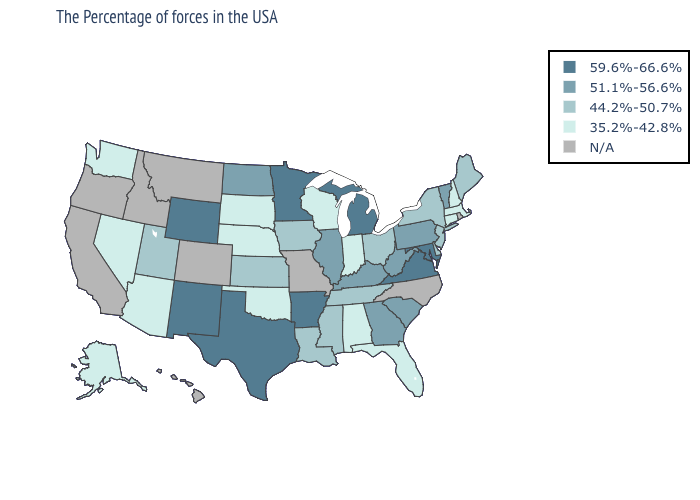Name the states that have a value in the range N/A?
Write a very short answer. Rhode Island, North Carolina, Missouri, Colorado, Montana, Idaho, California, Oregon, Hawaii. Name the states that have a value in the range 35.2%-42.8%?
Keep it brief. Massachusetts, New Hampshire, Connecticut, Florida, Indiana, Alabama, Wisconsin, Nebraska, Oklahoma, South Dakota, Arizona, Nevada, Washington, Alaska. Which states have the highest value in the USA?
Write a very short answer. Maryland, Virginia, Michigan, Arkansas, Minnesota, Texas, Wyoming, New Mexico. Among the states that border North Dakota , which have the highest value?
Short answer required. Minnesota. What is the value of Indiana?
Keep it brief. 35.2%-42.8%. What is the value of Missouri?
Write a very short answer. N/A. What is the highest value in states that border Oklahoma?
Be succinct. 59.6%-66.6%. What is the value of Texas?
Short answer required. 59.6%-66.6%. Among the states that border Maryland , which have the highest value?
Short answer required. Virginia. Name the states that have a value in the range 44.2%-50.7%?
Give a very brief answer. Maine, New York, New Jersey, Delaware, Ohio, Tennessee, Mississippi, Louisiana, Iowa, Kansas, Utah. Does Oklahoma have the lowest value in the South?
Give a very brief answer. Yes. What is the value of Alabama?
Give a very brief answer. 35.2%-42.8%. Is the legend a continuous bar?
Concise answer only. No. Name the states that have a value in the range 51.1%-56.6%?
Keep it brief. Vermont, Pennsylvania, South Carolina, West Virginia, Georgia, Kentucky, Illinois, North Dakota. 